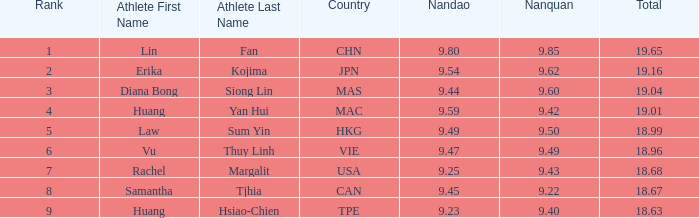Can you parse all the data within this table? {'header': ['Rank', 'Athlete First Name', 'Athlete Last Name', 'Country', 'Nandao', 'Nanquan', 'Total'], 'rows': [['1', 'Lin', 'Fan', 'CHN', '9.80', '9.85', '19.65'], ['2', 'Erika', 'Kojima', 'JPN', '9.54', '9.62', '19.16'], ['3', 'Diana Bong', 'Siong Lin', 'MAS', '9.44', '9.60', '19.04'], ['4', 'Huang', 'Yan Hui', 'MAC', '9.59', '9.42', '19.01'], ['5', 'Law', 'Sum Yin', 'HKG', '9.49', '9.50', '18.99'], ['6', 'Vu', 'Thuy Linh', 'VIE', '9.47', '9.49', '18.96'], ['7', 'Rachel', 'Margalit', 'USA', '9.25', '9.43', '18.68'], ['8', 'Samantha', 'Tjhia', 'CAN', '9.45', '9.22', '18.67'], ['9', 'Huang', 'Hsiao-Chien', 'TPE', '9.23', '9.40', '18.63']]} Which Nanquan has a Nandao larger than 9.49, and a Rank of 4? 9.42. 